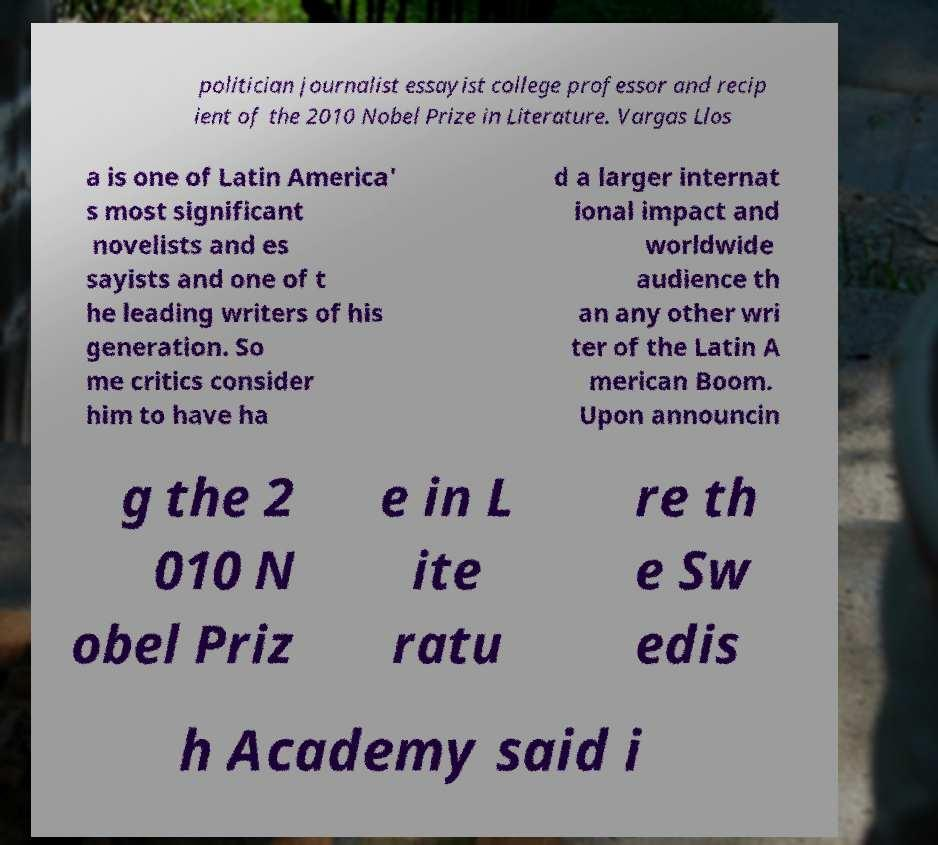Could you assist in decoding the text presented in this image and type it out clearly? politician journalist essayist college professor and recip ient of the 2010 Nobel Prize in Literature. Vargas Llos a is one of Latin America' s most significant novelists and es sayists and one of t he leading writers of his generation. So me critics consider him to have ha d a larger internat ional impact and worldwide audience th an any other wri ter of the Latin A merican Boom. Upon announcin g the 2 010 N obel Priz e in L ite ratu re th e Sw edis h Academy said i 